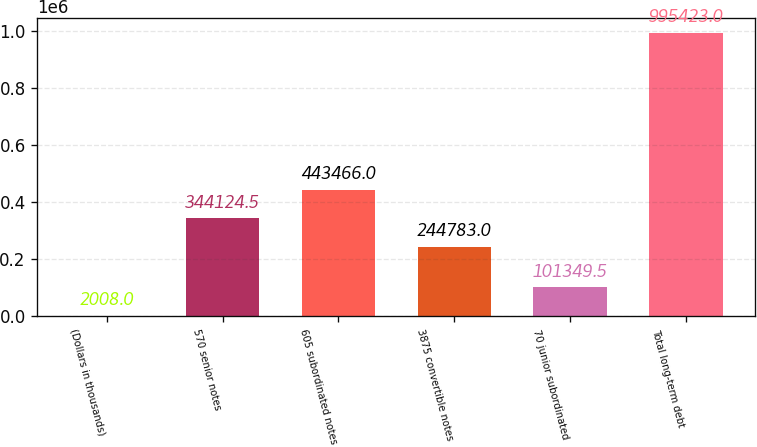Convert chart. <chart><loc_0><loc_0><loc_500><loc_500><bar_chart><fcel>(Dollars in thousands)<fcel>570 senior notes<fcel>605 subordinated notes<fcel>3875 convertible notes<fcel>70 junior subordinated<fcel>Total long-term debt<nl><fcel>2008<fcel>344124<fcel>443466<fcel>244783<fcel>101350<fcel>995423<nl></chart> 